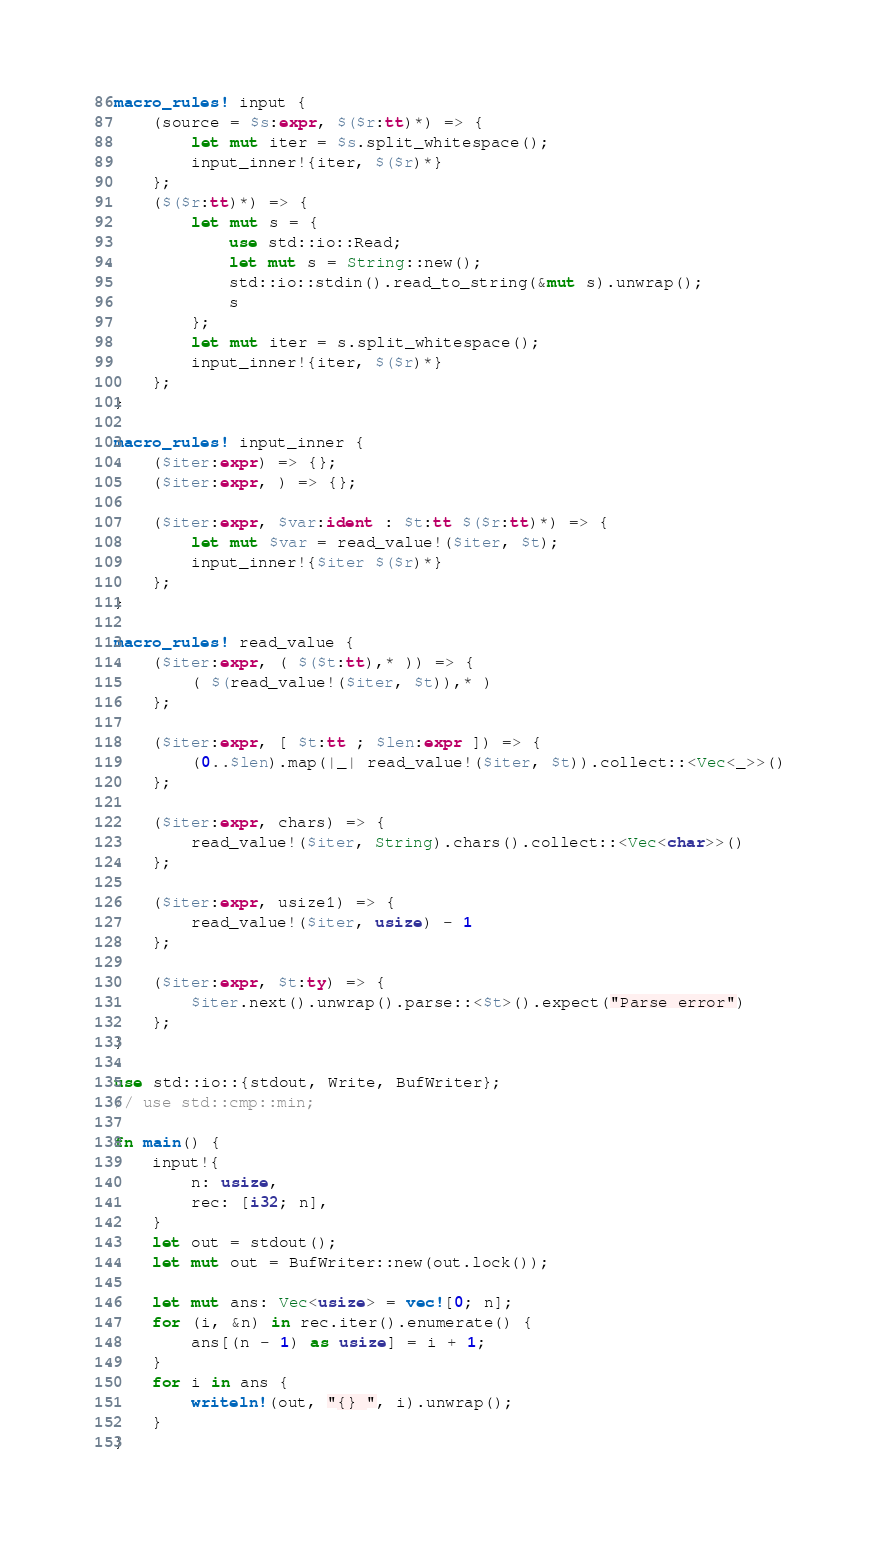Convert code to text. <code><loc_0><loc_0><loc_500><loc_500><_Rust_>macro_rules! input {
    (source = $s:expr, $($r:tt)*) => {
        let mut iter = $s.split_whitespace();
        input_inner!{iter, $($r)*}
    };
    ($($r:tt)*) => {
        let mut s = {
            use std::io::Read;
            let mut s = String::new();
            std::io::stdin().read_to_string(&mut s).unwrap();
            s
        };
        let mut iter = s.split_whitespace();
        input_inner!{iter, $($r)*}
    };
}

macro_rules! input_inner {
    ($iter:expr) => {};
    ($iter:expr, ) => {};

    ($iter:expr, $var:ident : $t:tt $($r:tt)*) => {
        let mut $var = read_value!($iter, $t);
        input_inner!{$iter $($r)*}
    };
}

macro_rules! read_value {
    ($iter:expr, ( $($t:tt),* )) => {
        ( $(read_value!($iter, $t)),* )
    };

    ($iter:expr, [ $t:tt ; $len:expr ]) => {
        (0..$len).map(|_| read_value!($iter, $t)).collect::<Vec<_>>()
    };

    ($iter:expr, chars) => {
        read_value!($iter, String).chars().collect::<Vec<char>>()
    };

    ($iter:expr, usize1) => {
        read_value!($iter, usize) - 1
    };

    ($iter:expr, $t:ty) => {
        $iter.next().unwrap().parse::<$t>().expect("Parse error")
    };
}

use std::io::{stdout, Write, BufWriter};
// use std::cmp::min;

fn main() {
    input!{
        n: usize,
        rec: [i32; n],
    }
    let out = stdout();
    let mut out = BufWriter::new(out.lock());

    let mut ans: Vec<usize> = vec![0; n];
    for (i, &n) in rec.iter().enumerate() {
        ans[(n - 1) as usize] = i + 1;
    }
    for i in ans {
        writeln!(out, "{} ", i).unwrap();
    }
}
</code> 